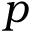<formula> <loc_0><loc_0><loc_500><loc_500>p</formula> 